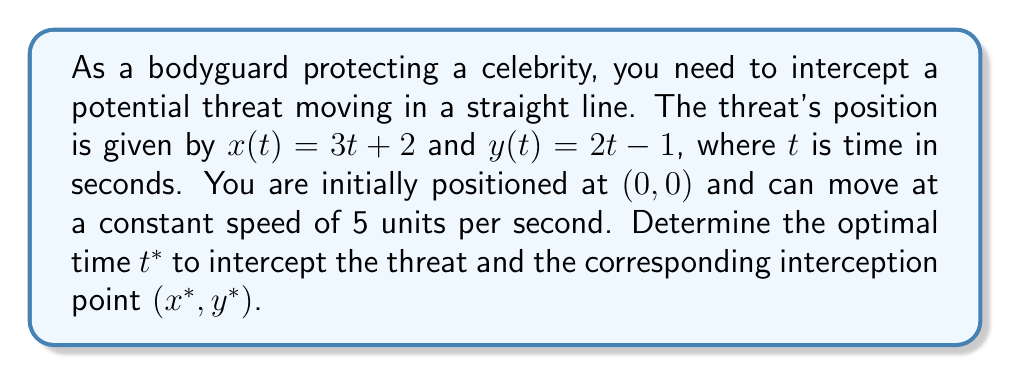What is the answer to this math problem? To solve this problem, we need to follow these steps:

1) First, we need to find the position of the threat at any given time $t$:
   $$(x, y) = (3t + 2, 2t - 1)$$

2) The distance between your initial position (0, 0) and the threat's position at time $t$ is:
   $$d(t) = \sqrt{(3t + 2)^2 + (2t - 1)^2}$$

3) Since you move at a constant speed of 5 units per second, the time it takes you to reach the interception point is $\frac{d(t)}{5}$.

4) For optimal interception, your travel time should equal the threat's travel time. This gives us the equation:
   $$t = \frac{d(t)}{5}$$

5) Substituting the expression for $d(t)$:
   $$t = \frac{\sqrt{(3t + 2)^2 + (2t - 1)^2}}{5}$$

6) Square both sides:
   $$25t^2 = (3t + 2)^2 + (2t - 1)^2$$

7) Expand:
   $$25t^2 = 9t^2 + 12t + 4 + 4t^2 - 4t + 1$$

8) Simplify:
   $$25t^2 = 13t^2 + 8t + 5$$

9) Rearrange:
   $$12t^2 - 8t - 5 = 0$$

10) This is a quadratic equation. Solve using the quadratic formula:
    $$t = \frac{-b \pm \sqrt{b^2 - 4ac}}{2a}$$
    where $a = 12$, $b = -8$, and $c = -5$

11) Solving:
    $$t^* = \frac{8 + \sqrt{64 + 240}}{24} = \frac{8 + \sqrt{304}}{24} \approx 1.0359$$

12) To find the interception point, substitute $t^*$ into the threat's position equations:
    $$x^* = 3t^* + 2 \approx 5.1077$$
    $$y^* = 2t^* - 1 \approx 1.0718$$
Answer: The optimal interception time is $t^* \approx 1.0359$ seconds, and the corresponding interception point is $(x^*, y^*) \approx (5.1077, 1.0718)$. 